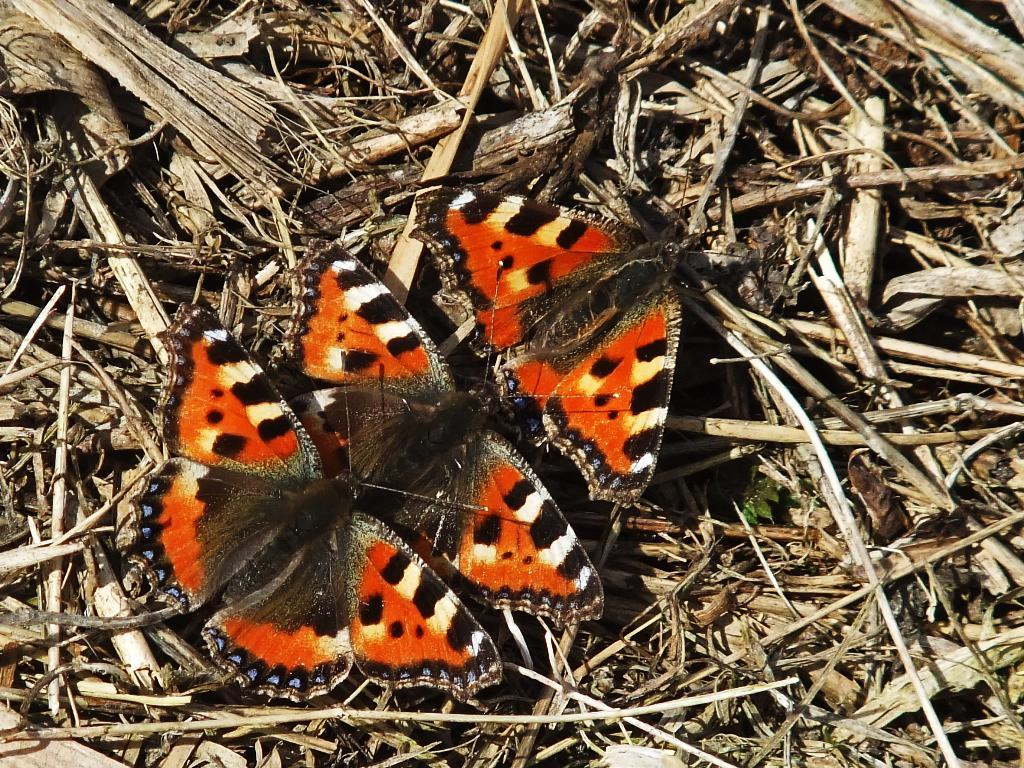How many butterflies are present in the image? There are three butterflies in the image. What are the butterflies resting on in the image? The butterflies are on dry wooden sticks. What type of shoes are the butterflies wearing in the image? Butterflies do not wear shoes, so this detail cannot be found in the image. 